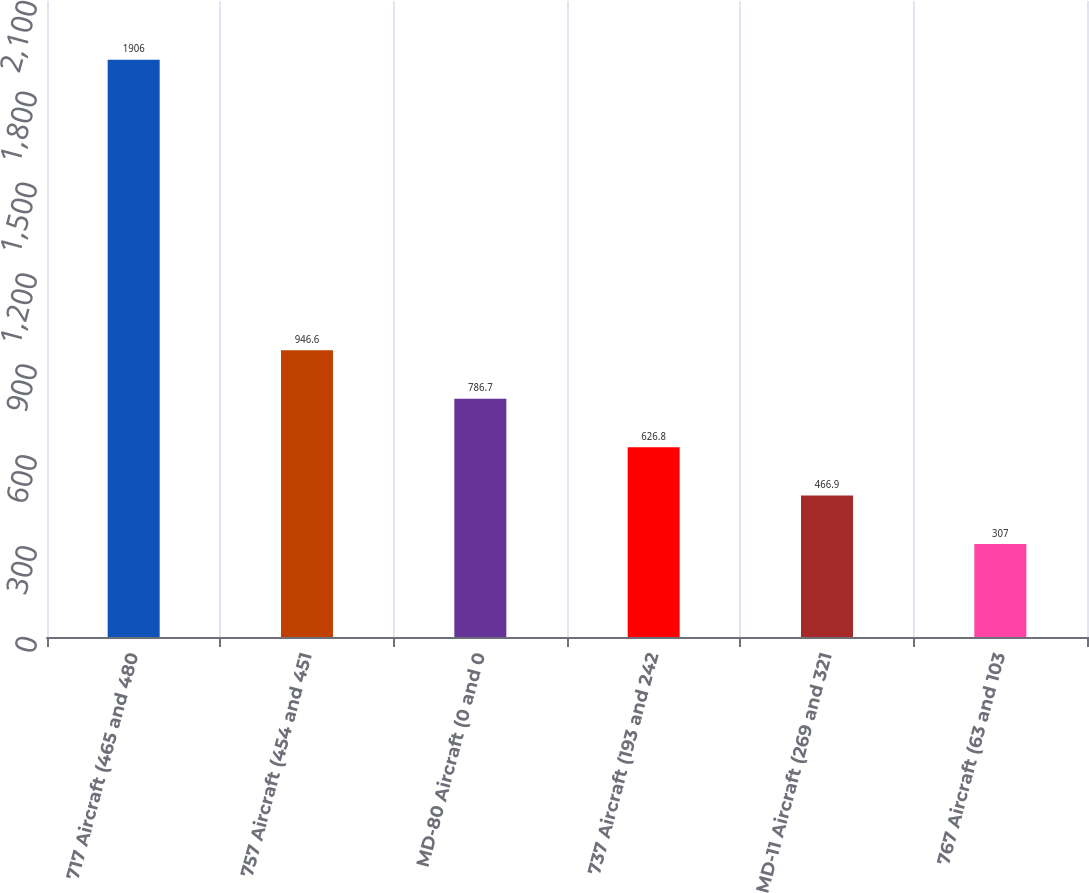Convert chart. <chart><loc_0><loc_0><loc_500><loc_500><bar_chart><fcel>717 Aircraft (465 and 480<fcel>757 Aircraft (454 and 451<fcel>MD-80 Aircraft (0 and 0<fcel>737 Aircraft (193 and 242<fcel>MD-11 Aircraft (269 and 321<fcel>767 Aircraft (63 and 103<nl><fcel>1906<fcel>946.6<fcel>786.7<fcel>626.8<fcel>466.9<fcel>307<nl></chart> 